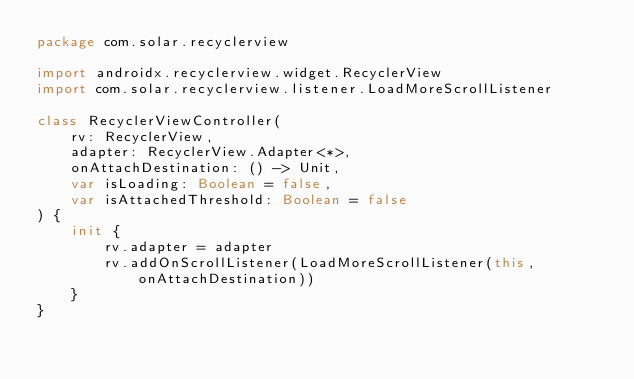Convert code to text. <code><loc_0><loc_0><loc_500><loc_500><_Kotlin_>package com.solar.recyclerview

import androidx.recyclerview.widget.RecyclerView
import com.solar.recyclerview.listener.LoadMoreScrollListener

class RecyclerViewController(
    rv: RecyclerView,
    adapter: RecyclerView.Adapter<*>,
    onAttachDestination: () -> Unit,
    var isLoading: Boolean = false,
    var isAttachedThreshold: Boolean = false
) {
    init {
        rv.adapter = adapter
        rv.addOnScrollListener(LoadMoreScrollListener(this, onAttachDestination))
    }
}
</code> 